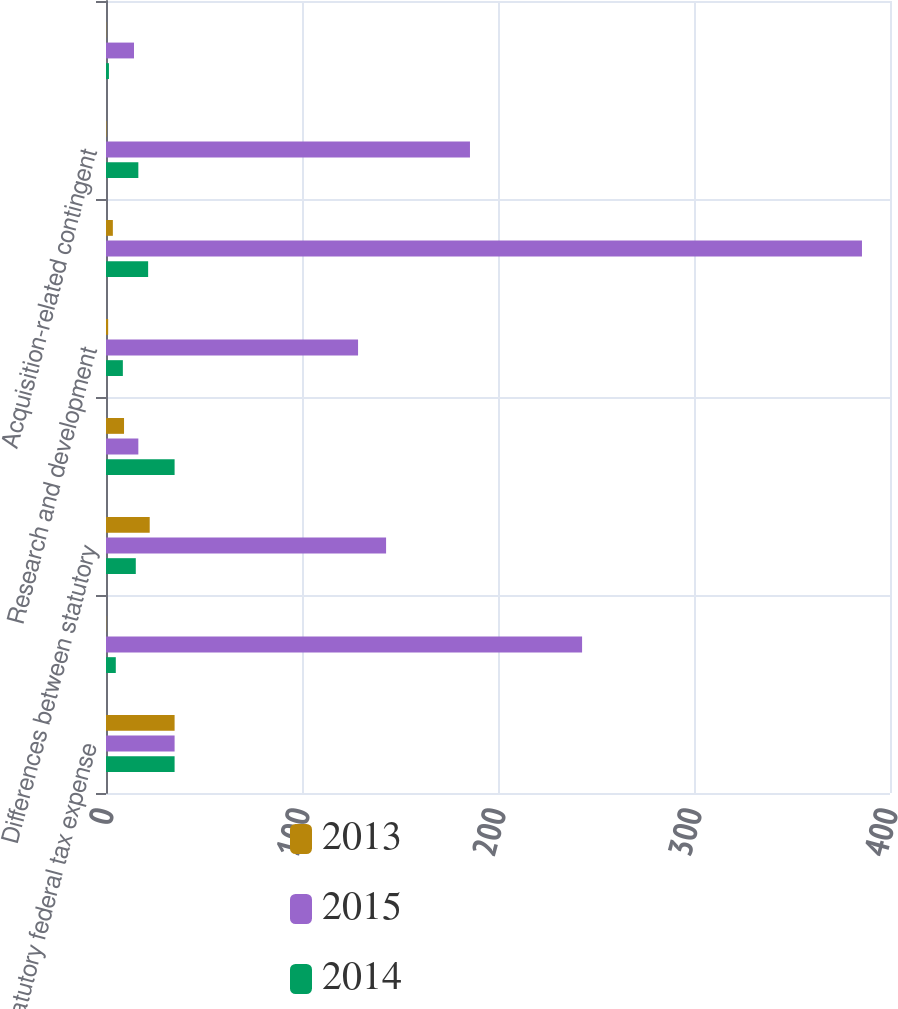Convert chart. <chart><loc_0><loc_0><loc_500><loc_500><stacked_bar_chart><ecel><fcel>Statutory federal tax expense<fcel>State taxes net of federal<fcel>Differences between statutory<fcel>Valuation allowance<fcel>Research and development<fcel>Non-deductible stock-based<fcel>Acquisition-related contingent<fcel>Other<nl><fcel>2013<fcel>35<fcel>0.1<fcel>22.3<fcel>9.2<fcel>1.1<fcel>3.5<fcel>0.2<fcel>0.1<nl><fcel>2015<fcel>35<fcel>242.9<fcel>142.9<fcel>16.5<fcel>128.6<fcel>385.7<fcel>185.7<fcel>14.3<nl><fcel>2014<fcel>35<fcel>5<fcel>15.2<fcel>35<fcel>8.6<fcel>21.5<fcel>16.5<fcel>1.5<nl></chart> 